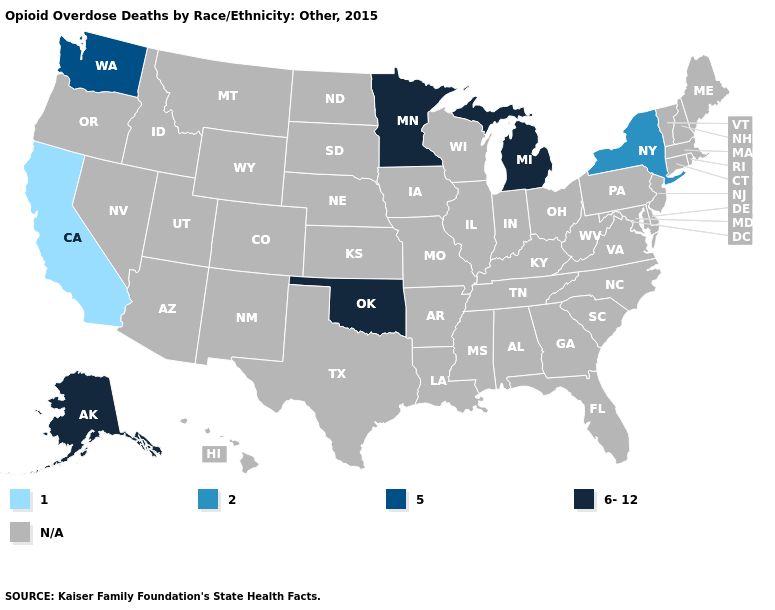What is the value of South Carolina?
Keep it brief. N/A. Name the states that have a value in the range N/A?
Quick response, please. Alabama, Arizona, Arkansas, Colorado, Connecticut, Delaware, Florida, Georgia, Hawaii, Idaho, Illinois, Indiana, Iowa, Kansas, Kentucky, Louisiana, Maine, Maryland, Massachusetts, Mississippi, Missouri, Montana, Nebraska, Nevada, New Hampshire, New Jersey, New Mexico, North Carolina, North Dakota, Ohio, Oregon, Pennsylvania, Rhode Island, South Carolina, South Dakota, Tennessee, Texas, Utah, Vermont, Virginia, West Virginia, Wisconsin, Wyoming. Name the states that have a value in the range 6-12?
Answer briefly. Alaska, Michigan, Minnesota, Oklahoma. What is the highest value in the Northeast ?
Answer briefly. 2. Name the states that have a value in the range N/A?
Keep it brief. Alabama, Arizona, Arkansas, Colorado, Connecticut, Delaware, Florida, Georgia, Hawaii, Idaho, Illinois, Indiana, Iowa, Kansas, Kentucky, Louisiana, Maine, Maryland, Massachusetts, Mississippi, Missouri, Montana, Nebraska, Nevada, New Hampshire, New Jersey, New Mexico, North Carolina, North Dakota, Ohio, Oregon, Pennsylvania, Rhode Island, South Carolina, South Dakota, Tennessee, Texas, Utah, Vermont, Virginia, West Virginia, Wisconsin, Wyoming. What is the value of Colorado?
Write a very short answer. N/A. Name the states that have a value in the range N/A?
Keep it brief. Alabama, Arizona, Arkansas, Colorado, Connecticut, Delaware, Florida, Georgia, Hawaii, Idaho, Illinois, Indiana, Iowa, Kansas, Kentucky, Louisiana, Maine, Maryland, Massachusetts, Mississippi, Missouri, Montana, Nebraska, Nevada, New Hampshire, New Jersey, New Mexico, North Carolina, North Dakota, Ohio, Oregon, Pennsylvania, Rhode Island, South Carolina, South Dakota, Tennessee, Texas, Utah, Vermont, Virginia, West Virginia, Wisconsin, Wyoming. What is the value of Hawaii?
Concise answer only. N/A. Does the first symbol in the legend represent the smallest category?
Quick response, please. Yes. Among the states that border New Jersey , which have the highest value?
Keep it brief. New York. Which states have the lowest value in the South?
Concise answer only. Oklahoma. 